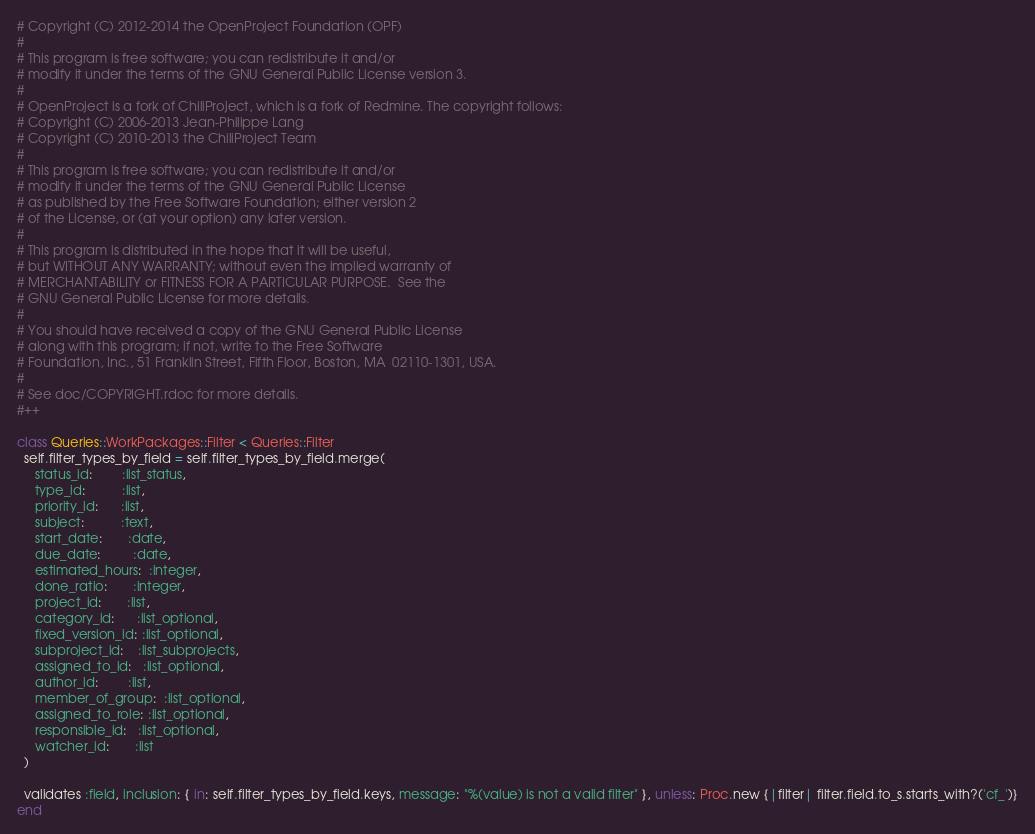Convert code to text. <code><loc_0><loc_0><loc_500><loc_500><_Ruby_># Copyright (C) 2012-2014 the OpenProject Foundation (OPF)
#
# This program is free software; you can redistribute it and/or
# modify it under the terms of the GNU General Public License version 3.
#
# OpenProject is a fork of ChiliProject, which is a fork of Redmine. The copyright follows:
# Copyright (C) 2006-2013 Jean-Philippe Lang
# Copyright (C) 2010-2013 the ChiliProject Team
#
# This program is free software; you can redistribute it and/or
# modify it under the terms of the GNU General Public License
# as published by the Free Software Foundation; either version 2
# of the License, or (at your option) any later version.
#
# This program is distributed in the hope that it will be useful,
# but WITHOUT ANY WARRANTY; without even the implied warranty of
# MERCHANTABILITY or FITNESS FOR A PARTICULAR PURPOSE.  See the
# GNU General Public License for more details.
#
# You should have received a copy of the GNU General Public License
# along with this program; if not, write to the Free Software
# Foundation, Inc., 51 Franklin Street, Fifth Floor, Boston, MA  02110-1301, USA.
#
# See doc/COPYRIGHT.rdoc for more details.
#++

class Queries::WorkPackages::Filter < Queries::Filter
  self.filter_types_by_field = self.filter_types_by_field.merge(
     status_id:        :list_status,
     type_id:          :list,
     priority_id:      :list,
     subject:          :text,
     start_date:       :date,
     due_date:         :date,
     estimated_hours:  :integer,
     done_ratio:       :integer,
     project_id:       :list,
     category_id:      :list_optional,
     fixed_version_id: :list_optional,
     subproject_id:    :list_subprojects,
     assigned_to_id:   :list_optional,
     author_id:        :list,
     member_of_group:  :list_optional,
     assigned_to_role: :list_optional,
     responsible_id:   :list_optional,
     watcher_id:       :list
  )

  validates :field, inclusion: { in: self.filter_types_by_field.keys, message: "%(value) is not a valid filter" }, unless: Proc.new {|filter| filter.field.to_s.starts_with?('cf_')}
end
</code> 